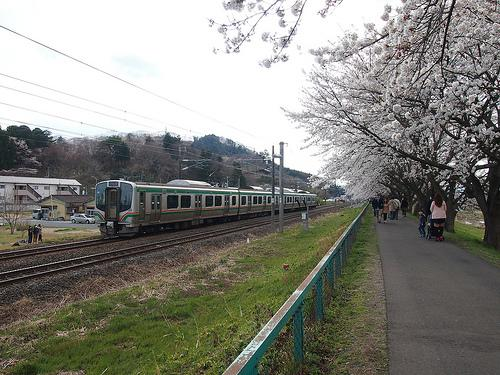Mention the type of fence bordering the pedestrian walkway. A weathered green and chain link fence. Identify the type of trees with blossoms in the image. Cherry blossom trees. What type of residential buildings can be seen in this scene? Yellow house with a grey roof, white apartment building, and beige apartment building. State one activity involving a child and an adult in the image. A young child walking with his mother along a pathway. Count the number of people visible in the image. At least 8 people, including a woman pushing a stroller, a child with his mother, a couple, and a group of people conversing. Describe the state of the sky in the photograph. The sky is gray. List three features that can be seen along the pedestrian walkway in this picture. Smooth blacktop walkway, cherry blossom trees, and people walking. Describe the overall sentiment conveyed by the image. A peaceful, everyday scene at a railway with people enjoying a walk and cherry blossoms in bloom. Name the object that supplies electricity to the train. Utility lines for the electric train. What is the primary mode of transportation shown in this image? A green, orange, white, and silver passenger train on a railway. Provide a brief description of the pedestrian walkway. Smooth blacktop pathway What are the pedestrians doing on the path? Walking and conversing Describe the style of the row of trees in full blossom. Cherry blossom trees Describe the interaction between the path and the fence. The fence is beside the path Can you spot the purple bicycle leaning against the fence? No, it's not mentioned in the image. What activity is the lady with the stroller engaged in? Walking with her child What is the main subject of the picture with the blossoming trees? Cherry blossom trees along a walkway What type of train is in the image? A green, orange, white, and silver passenger train What is the significance of the power lines in this image? They are for the electric train Which object is referred to as "a smooth blacktop walkway" in the image? The path What is a common feature among the group of people on the path? They are all walking What type of building is white in color? Apartment building What is the woman in the pink blazer doing? Pushing a baby stroller Describe the color of the fence separating the railway tracks and the pedestrian walkway. Light green and rusted Count the number of cherry blossom trees along the walkway. A row of cherry trees Identify the primary colors of the train in the image. Green and orange How many train tracks are in the image? Two train tracks How is the fence described in the image? Weathered, green, and chain link Which of the following options best describes the color of the house? A) Yellow and grey B) Blue and white C) Red and black A) Yellow and grey 